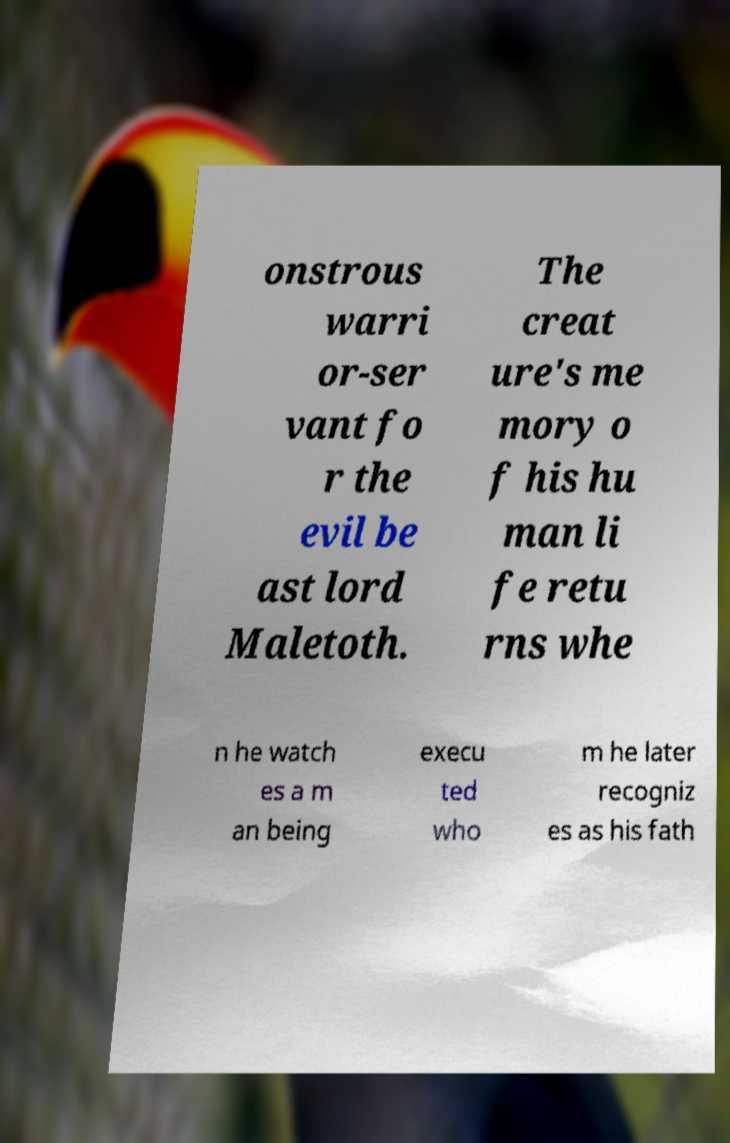Could you assist in decoding the text presented in this image and type it out clearly? onstrous warri or-ser vant fo r the evil be ast lord Maletoth. The creat ure's me mory o f his hu man li fe retu rns whe n he watch es a m an being execu ted who m he later recogniz es as his fath 